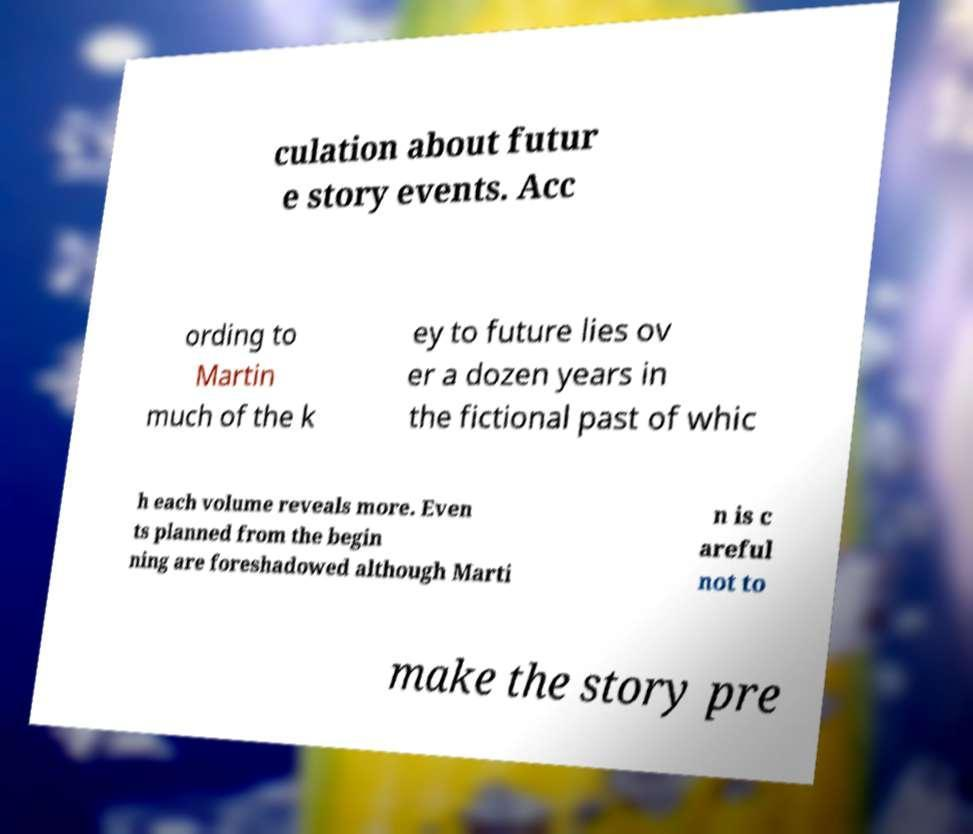I need the written content from this picture converted into text. Can you do that? culation about futur e story events. Acc ording to Martin much of the k ey to future lies ov er a dozen years in the fictional past of whic h each volume reveals more. Even ts planned from the begin ning are foreshadowed although Marti n is c areful not to make the story pre 